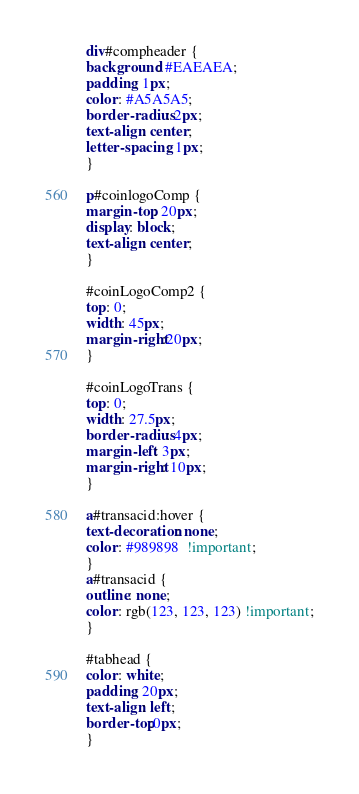Convert code to text. <code><loc_0><loc_0><loc_500><loc_500><_CSS_>div#compheader {
background: #EAEAEA;
padding: 1px;
color: #A5A5A5;
border-radius: 2px;
text-align: center;
letter-spacing: 1px;
} 

p#coinlogoComp {
margin-top: 20px;
display: block;
text-align: center;
}

#coinLogoComp2 {
top: 0;
width: 45px;
margin-right:20px;
}

#coinLogoTrans {
top: 0;
width: 27.5px;
border-radius: 4px;
margin-left: 3px;
margin-right: 10px;
}

a#transacid:hover {
text-decoration: none;
color: #989898  !important;
}
a#transacid {
outline: none;
color: rgb(123, 123, 123) !important;
}

#tabhead {
color: white;
padding: 20px;
text-align: left;
border-top:0px;
}


</code> 